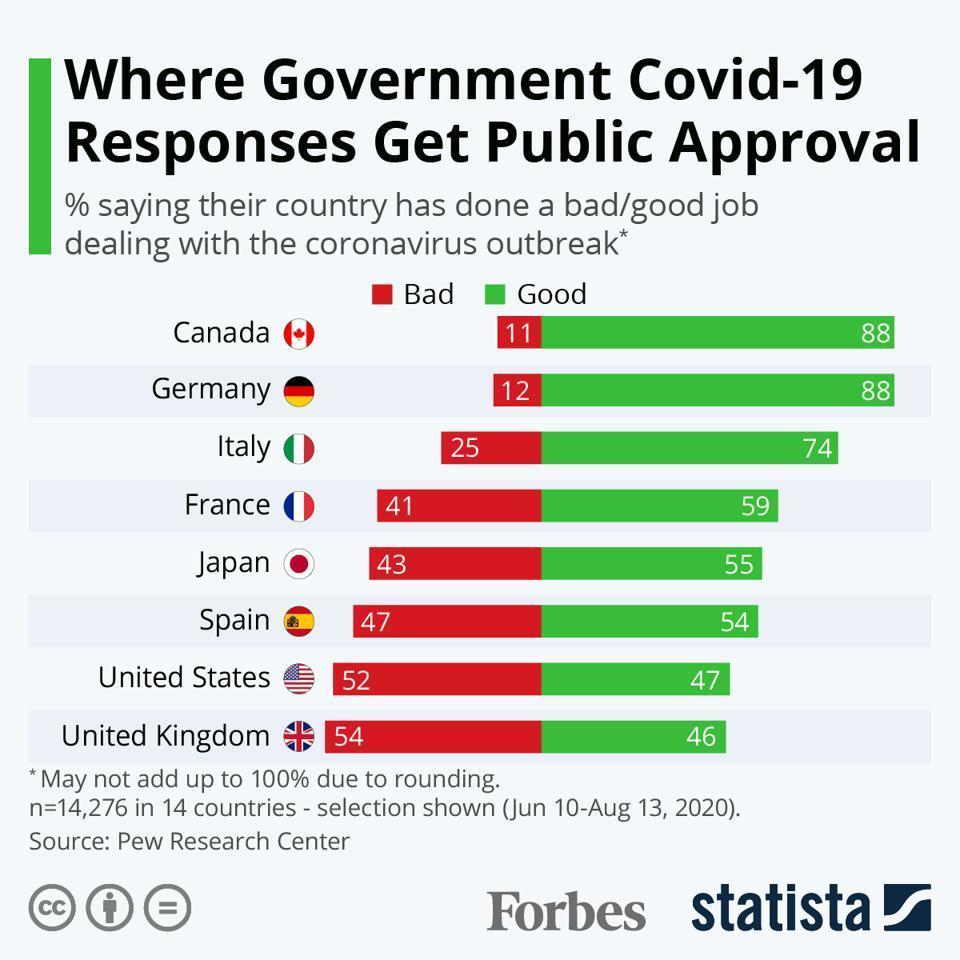What is the majority response the people of UK about the government dealing covid-19 outbreak - good or bad?
Answer the question with a short phrase. bad What is the percentage of good responses of the people of UK about the government dealing with covid-19 outbreak? 46 Which government got most number of bad responses from the public? United Kingdom How many countries are listed in this data visualization? 8 What is the percentage of bad responses Japan government have received from the public? 43% What is the majority response the people of Germany about the government dealing covid-19 outbreak - good or bad? good What is the percentage of good response of the people of Spain about the government dealing with covid-19 outbreak? 54 Which governments have received more than 70% good responses from the public? Canada, Germany, Italy Which governments have received bad responses than good from the public? United states, United Kingdom What is the majority response the people of France about the government dealing covid-19 outbreak - good or bad? good What is the majority response the people of Canada about the government dealing covid-19 outbreak - good or bad? good What is the percentage of bad responses France government have received from the public? 41% What is the percentage of bad responses United states government have received from the public? 52 What is the percentage of good response of the people of Italy about the government dealing with covid-19 outbreak? 74 Which governments have received highest percentage of good responses from the public? Canada, Germany 